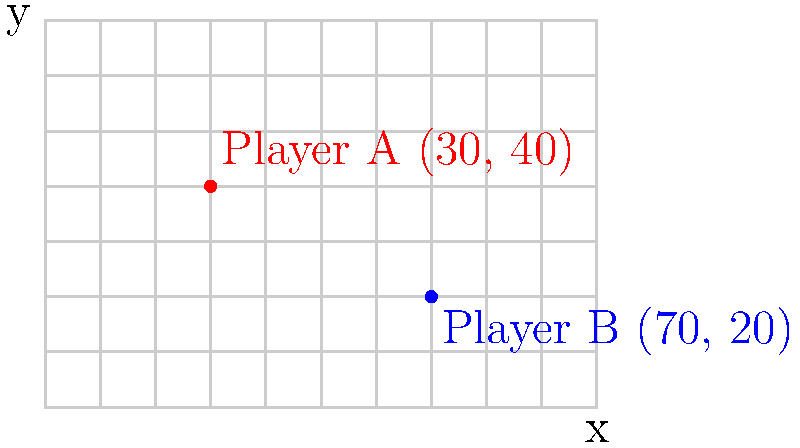During a crucial moment in an amateur club game, you need to quickly assess the distance between two players on the field. Player A is positioned at coordinates (30, 40), while Player B is at (70, 20). Using the coordinate system shown in the diagram, calculate the straight-line distance between the two players. Round your answer to the nearest meter. To find the distance between two points in a coordinate system, we can use the distance formula, which is derived from the Pythagorean theorem:

$$ d = \sqrt{(x_2 - x_1)^2 + (y_2 - y_1)^2} $$

Where $(x_1, y_1)$ are the coordinates of Player A and $(x_2, y_2)$ are the coordinates of Player B.

Step 1: Identify the coordinates
Player A: $(x_1, y_1) = (30, 40)$
Player B: $(x_2, y_2) = (70, 20)$

Step 2: Plug the values into the distance formula
$$ d = \sqrt{(70 - 30)^2 + (20 - 40)^2} $$

Step 3: Simplify the expressions inside the parentheses
$$ d = \sqrt{(40)^2 + (-20)^2} $$

Step 4: Calculate the squares
$$ d = \sqrt{1600 + 400} $$

Step 5: Add the values under the square root
$$ d = \sqrt{2000} $$

Step 6: Calculate the square root
$$ d \approx 44.72 $$

Step 7: Round to the nearest meter
$$ d \approx 45 \text{ meters} $$
Answer: 45 meters 